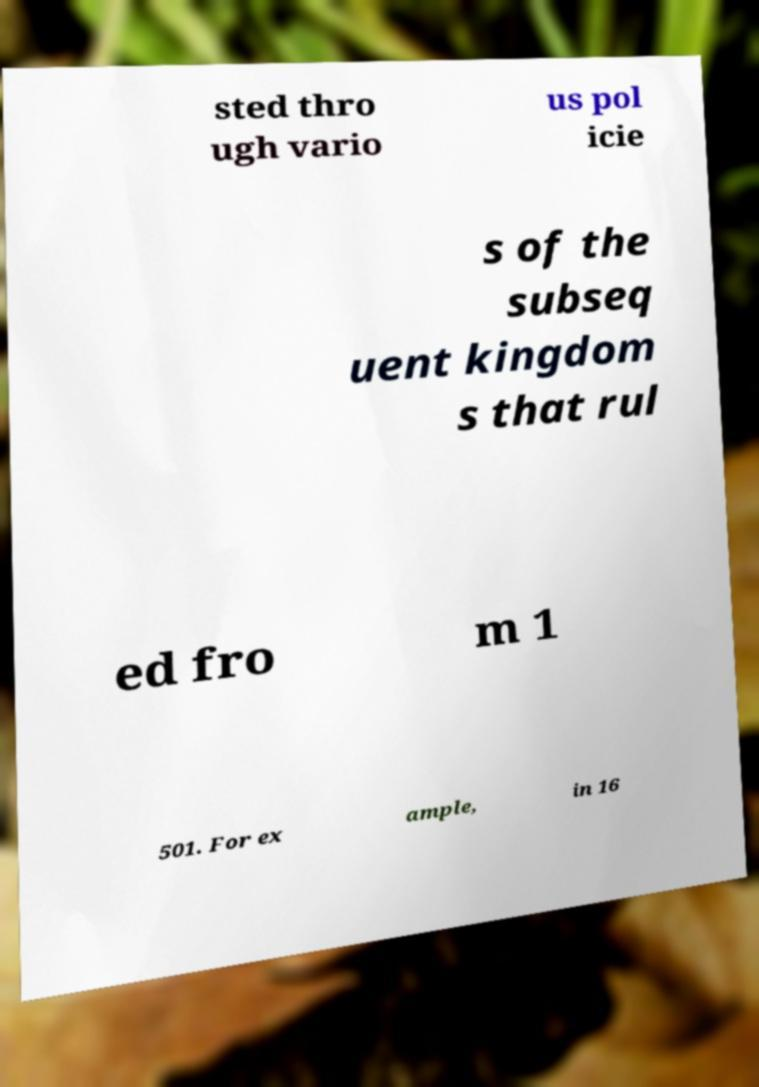What messages or text are displayed in this image? I need them in a readable, typed format. sted thro ugh vario us pol icie s of the subseq uent kingdom s that rul ed fro m 1 501. For ex ample, in 16 